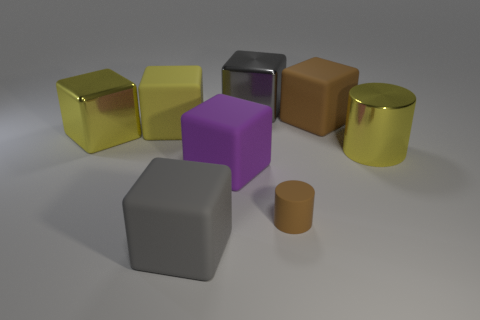What shape is the big matte object that is the same color as the rubber cylinder?
Make the answer very short. Cube. How many other gray things have the same shape as the gray rubber object?
Your answer should be compact. 1. There is a cylinder that is made of the same material as the big purple cube; what size is it?
Give a very brief answer. Small. Do the purple cube and the brown block have the same size?
Keep it short and to the point. Yes. Are there any matte cubes?
Offer a very short reply. Yes. The rubber cube that is the same color as the small rubber cylinder is what size?
Your answer should be very brief. Large. There is a brown rubber object behind the large metallic thing that is on the left side of the gray cube that is in front of the big brown thing; what size is it?
Provide a short and direct response. Large. How many brown things are the same material as the yellow cylinder?
Make the answer very short. 0. What number of gray things have the same size as the brown rubber cube?
Ensure brevity in your answer.  2. What is the big gray block behind the yellow metal object that is to the right of the brown matte object that is in front of the large yellow cylinder made of?
Your response must be concise. Metal. 